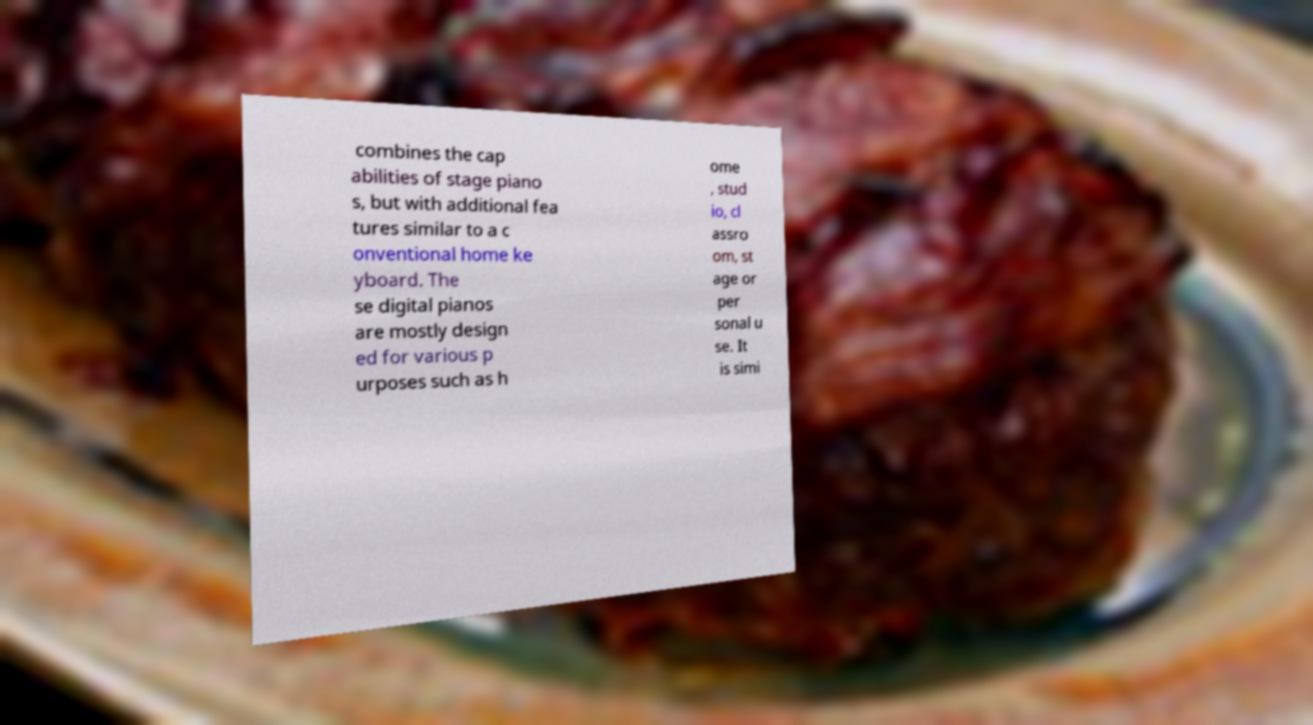Could you assist in decoding the text presented in this image and type it out clearly? combines the cap abilities of stage piano s, but with additional fea tures similar to a c onventional home ke yboard. The se digital pianos are mostly design ed for various p urposes such as h ome , stud io, cl assro om, st age or per sonal u se. It is simi 